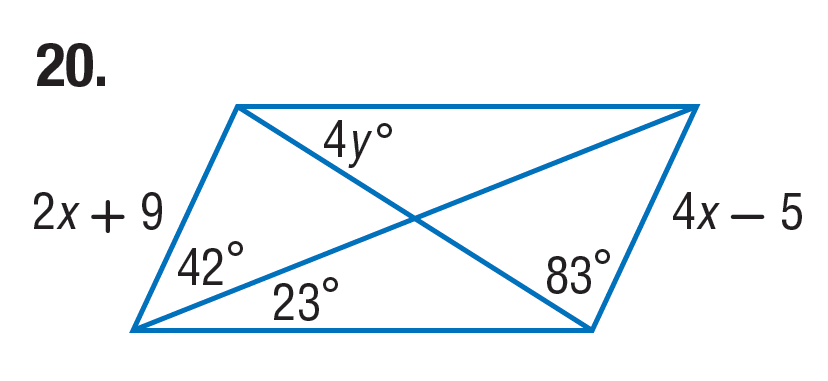Question: Find x in the parallelogram.
Choices:
A. 7
B. 14
C. 15
D. 23
Answer with the letter. Answer: A Question: Find y in the parallelogram.
Choices:
A. 8
B. 15
C. 16
D. 32
Answer with the letter. Answer: A 